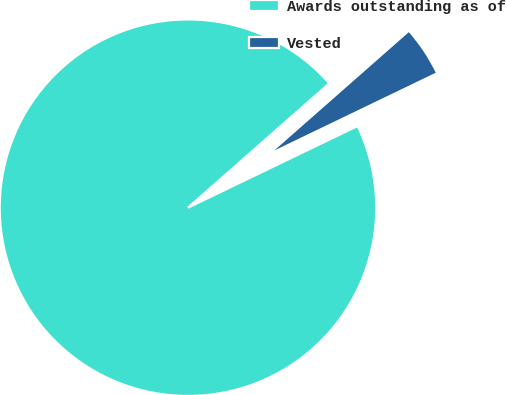<chart> <loc_0><loc_0><loc_500><loc_500><pie_chart><fcel>Awards outstanding as of<fcel>Vested<nl><fcel>95.66%<fcel>4.34%<nl></chart> 